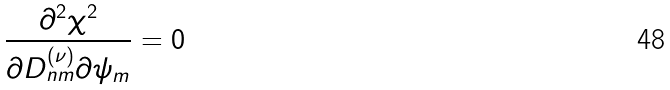<formula> <loc_0><loc_0><loc_500><loc_500>\frac { \partial ^ { 2 } \chi ^ { 2 } } { \partial D _ { n m } ^ { ( \nu ) } \partial \psi _ { m } } = 0</formula> 